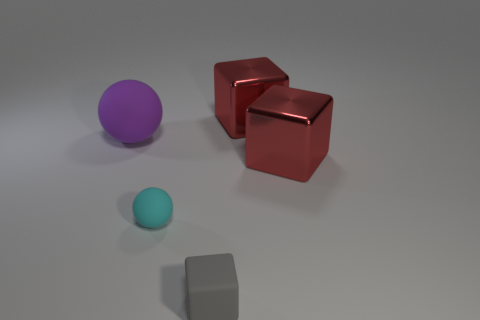There is a red block in front of the purple thing; is it the same size as the big purple matte thing?
Provide a succinct answer. Yes. The tiny rubber object on the right side of the small cyan sphere is what color?
Give a very brief answer. Gray. What is the color of the other thing that is the same shape as the cyan matte object?
Ensure brevity in your answer.  Purple. How many blocks are left of the red shiny block that is in front of the big cube that is behind the purple object?
Your answer should be very brief. 2. Is there anything else that is made of the same material as the gray block?
Give a very brief answer. Yes. Are there fewer small rubber cubes that are behind the tiny ball than small purple matte balls?
Provide a short and direct response. No. Is the color of the big matte thing the same as the matte block?
Give a very brief answer. No. The purple thing that is the same shape as the cyan object is what size?
Give a very brief answer. Large. What number of brown cylinders have the same material as the small gray cube?
Provide a succinct answer. 0. Are the tiny thing that is behind the tiny gray matte block and the purple object made of the same material?
Provide a succinct answer. Yes. 